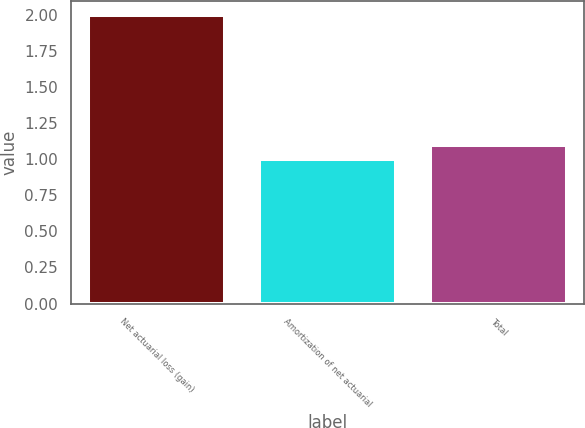<chart> <loc_0><loc_0><loc_500><loc_500><bar_chart><fcel>Net actuarial loss (gain)<fcel>Amortization of net actuarial<fcel>Total<nl><fcel>2<fcel>1<fcel>1.1<nl></chart> 